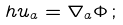<formula> <loc_0><loc_0><loc_500><loc_500>h u _ { a } = \nabla _ { a } \Phi \, ;</formula> 